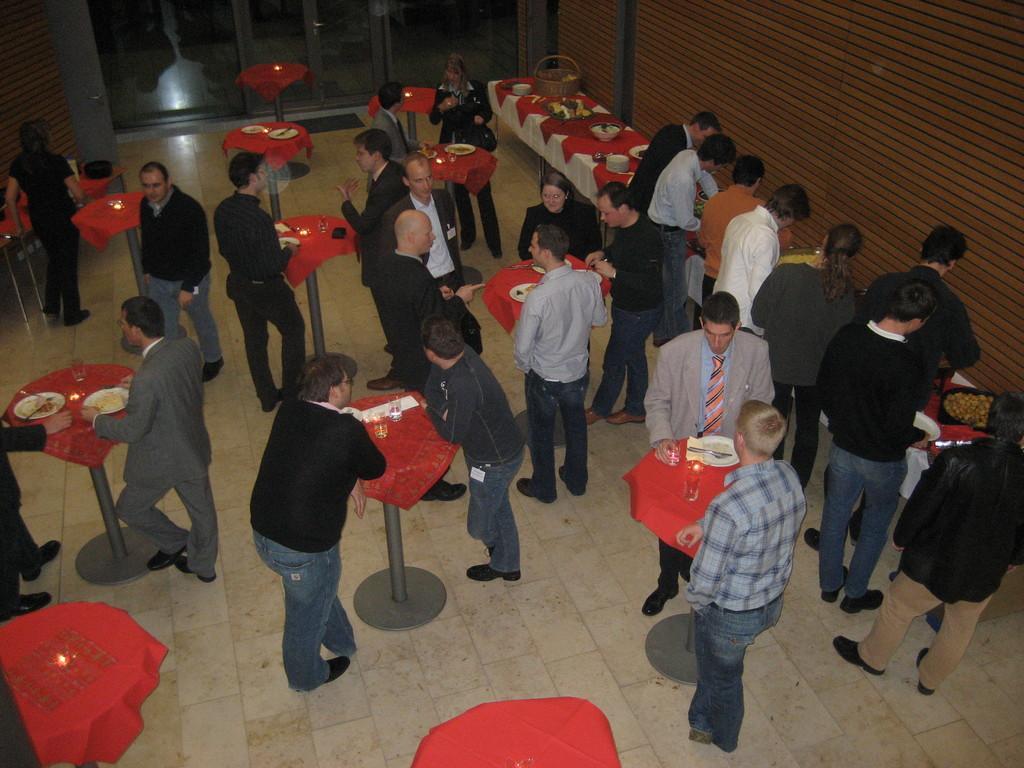How would you summarize this image in a sentence or two? In this image I see the floor on which there are number of people and I see number of tables on which there are food items and I see number of glasses and I see the wall. 